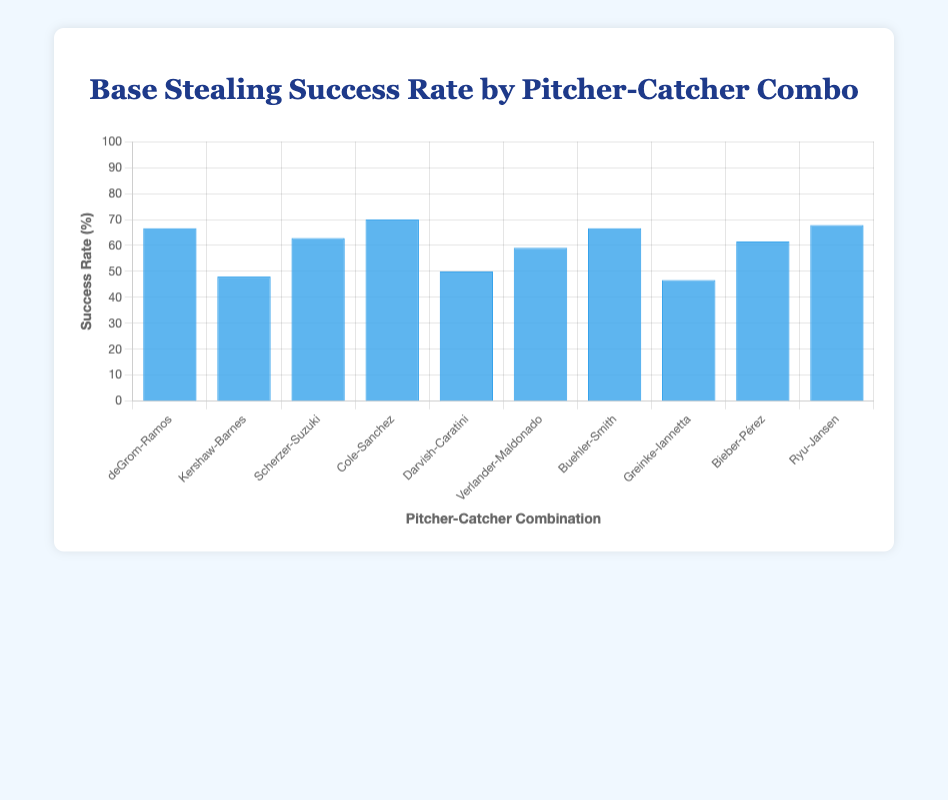Which pitcher-catcher combination has the highest success rate? Look for the tallest bar in the chart. Gerrit Cole-Gary Sanchez has the tallest bar, representing the highest success rate of 70%.
Answer: Gerrit Cole-Gary Sanchez Between Yu Darvish-Victor Caratini and Zack Greinke-Chris Iannetta combinations, which has a higher success rate? Compare the heights of the bars for Yu Darvish-Victor Caratini and Zack Greinke-Chris Iannetta. Yu Darvish-Victor Caratini's bar is taller, with a success rate of 50%, compared to Zack Greinke-Chris Iannetta's 46.67%.
Answer: Yu Darvish-Victor Caratini What is the average success rate of Justin Verlander-Martin Maldonado and Walker Buehler-Will Smith combinations? Add the success rates and divide by the number of pairs: (59.09 + 66.67) / 2 = 125.76 / 2 = 62.88%.
Answer: 62.88% Which combinations have exactly the same success rate? Look for bars of equal height. Jacob deGrom-Wilson Ramos and Walker Buehler-Will Smith have the same success rate of 66.67%.
Answer: Jacob deGrom-Wilson Ramos and Walker Buehler-Will Smith Is the success rate of Shane Bieber-Roberto Pérez higher or lower than Max Scherzer-Kurt Suzuki? Compare the heights of the bars for Shane Bieber-Roberto Pérez (61.54%) and Max Scherzer-Kurt Suzuki (62.86%). Shane Bieber-Roberto Pérez is lower.
Answer: Lower By how much is Gerrit Cole-Gary Sanchez's success rate higher than Clayton Kershaw-Austin Barnes? Subtract the success rates: 70% (Gerrit Cole-Gary Sanchez) - 48% (Clayton Kershaw-Austin Barnes) = 22%.
Answer: 22% What is the total number of successful steals combined by Jacob deGrom-Wilson Ramos and Hyun-Jin Ryu-Danny Jansen? Add the number of successful steals: 20 (deGrom-Ramos) + 19 (Ryu-Jansen) = 39.
Answer: 39 Which combination has the lowest success rate and what is it? Look for the shortest bar. Zack Greinke-Chris Iannetta has the shortest bar, representing a success rate of 46.67%.
Answer: Zack Greinke-Chris Iannetta, 46.67% Between Max Scherzer-Kurt Suzuki and Shane Bieber-Roberto Pérez, which combination had more stolen base attempts? Compare the stolen base attempts: Max Scherzer-Kurt Suzuki had 35 attempts, Shane Bieber-Roberto Pérez had 26. Max Scherzer-Kurt Suzuki had more attempts.
Answer: Max Scherzer-Kurt Suzuki 